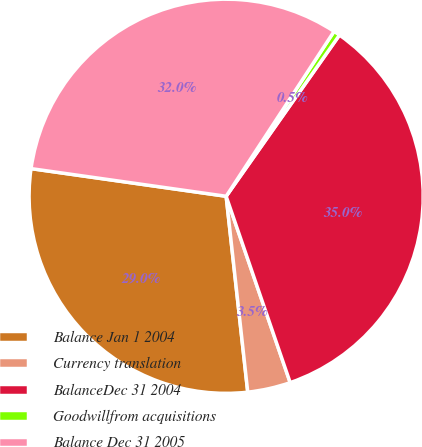<chart> <loc_0><loc_0><loc_500><loc_500><pie_chart><fcel>Balance Jan 1 2004<fcel>Currency translation<fcel>BalanceDec 31 2004<fcel>Goodwillfrom acquisitions<fcel>Balance Dec 31 2005<nl><fcel>28.99%<fcel>3.52%<fcel>34.98%<fcel>0.53%<fcel>31.98%<nl></chart> 